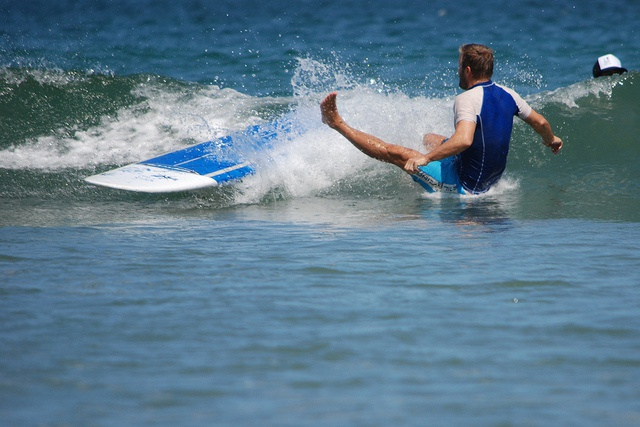Describe the objects in this image and their specific colors. I can see people in darkblue, black, navy, maroon, and lightgray tones and surfboard in darkblue, lightgray, darkgray, and blue tones in this image. 